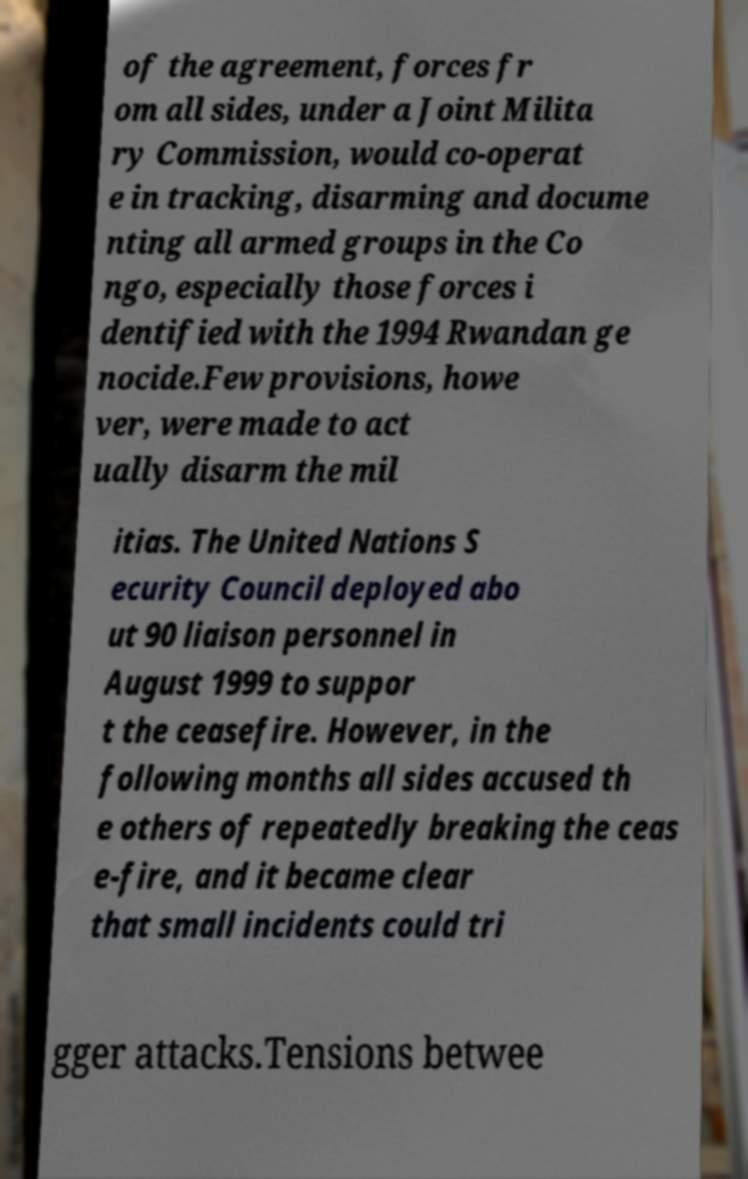Can you accurately transcribe the text from the provided image for me? of the agreement, forces fr om all sides, under a Joint Milita ry Commission, would co-operat e in tracking, disarming and docume nting all armed groups in the Co ngo, especially those forces i dentified with the 1994 Rwandan ge nocide.Few provisions, howe ver, were made to act ually disarm the mil itias. The United Nations S ecurity Council deployed abo ut 90 liaison personnel in August 1999 to suppor t the ceasefire. However, in the following months all sides accused th e others of repeatedly breaking the ceas e-fire, and it became clear that small incidents could tri gger attacks.Tensions betwee 